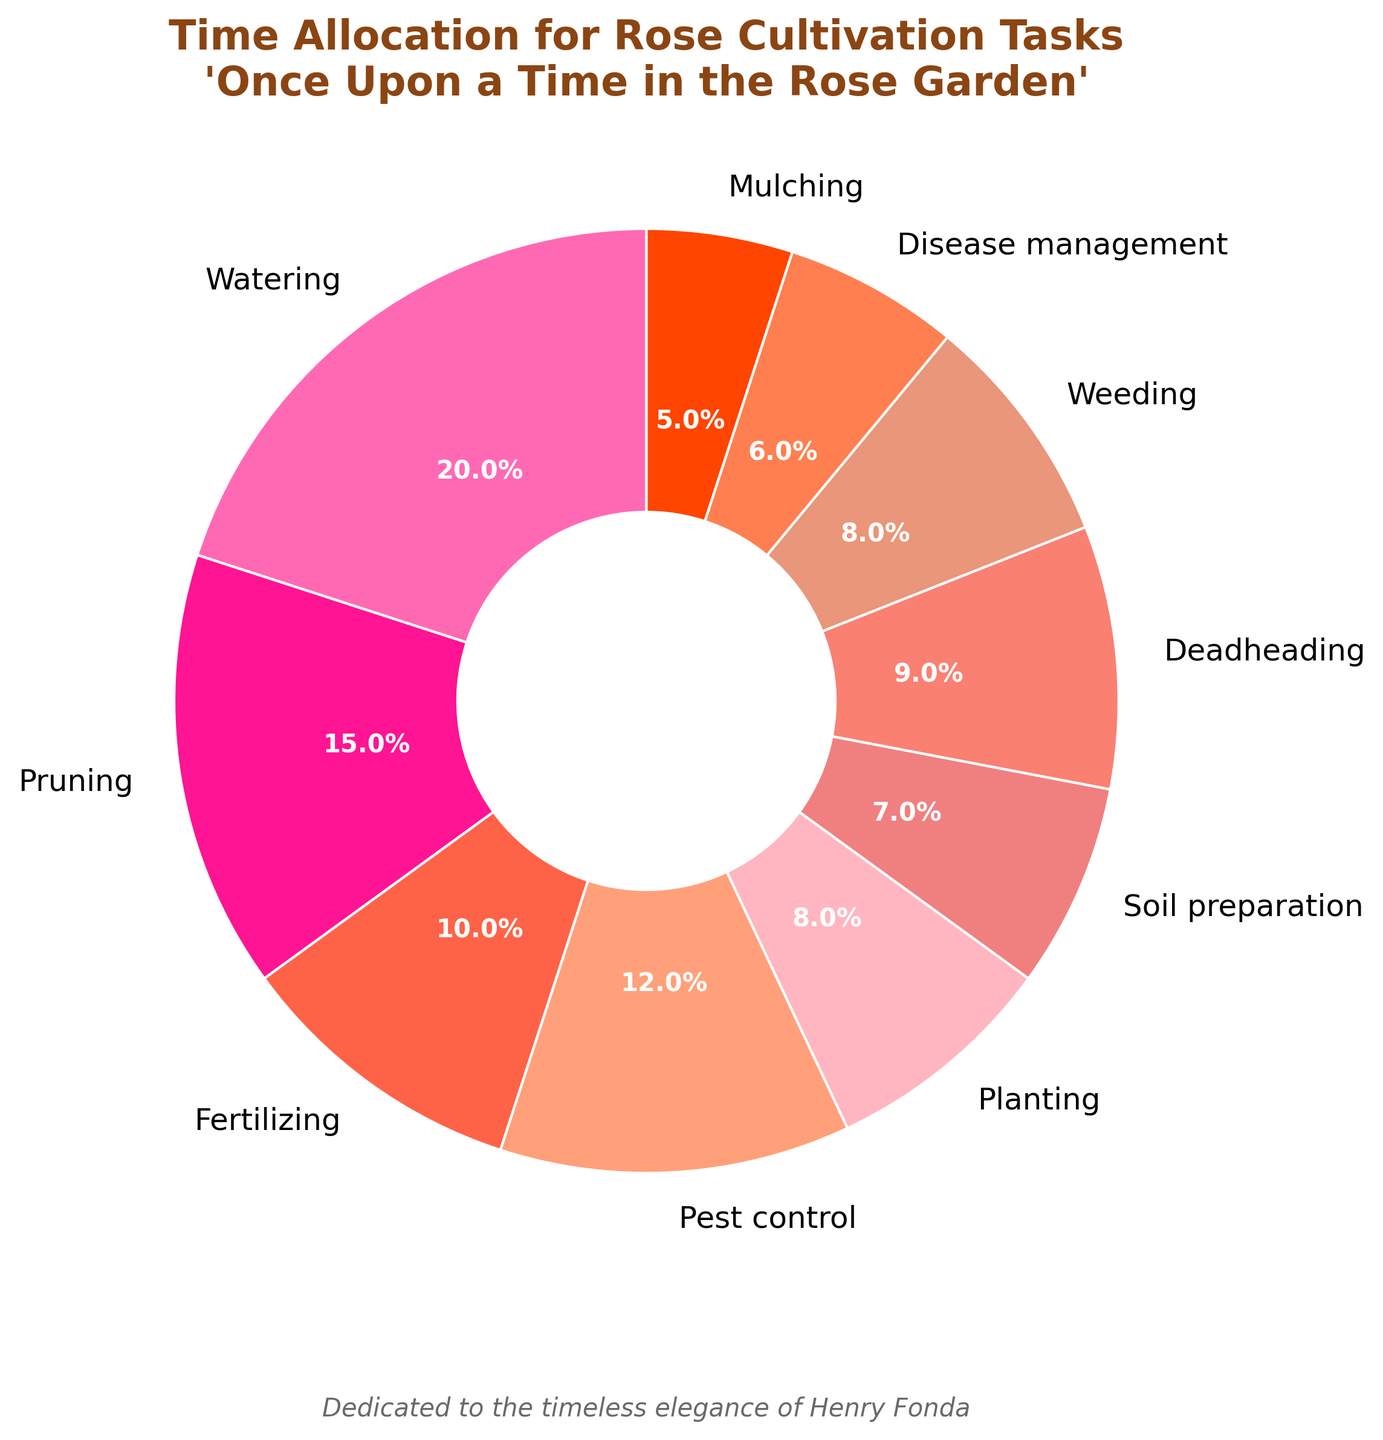Which task takes up the most time in rose cultivation? The task that has the highest percentage in the pie chart represents the task that takes up the most time. Here, Watering has the highest percentage of 20%.
Answer: Watering What is the combined percentage of time spent on planting and weeding? To find the combined percentage, add the percentages of Planting and Weeding. Planting has 8% and Weeding has 8%, so the total is 8% + 8% = 16%.
Answer: 16% Which task takes up more time, Deadheading or Fertilizing? Compare the percentages associated with Deadheading and Fertilizing tasks. Deadheading has 9% while Fertilizing has 10%. Therefore, Fertilizing takes up more time.
Answer: Fertilizing What is the least time-consuming task in rose cultivation? The least time-consuming task will have the smallest percentage in the pie chart. Here, Mulching is the least with 5%.
Answer: Mulching How much more time is spent on Pest control compared to Disease management? Subtract the percentage of Disease Management from Pest Control. Pest Control has 12% and Disease Management has 6%, so the difference is 12% - 6% = 6%.
Answer: 6% What is the total percentage of time spent on tasks related to the soil (Soil preparation and Mulching)? Add the percentages of Soil Preparation and Mulching together. Soil Preparation has 7% and Mulching has 5%, so total is 7% + 5% = 12%.
Answer: 12% Which tasks combined take up as much time as Pruning? Identify tasks whose percentages add up to the percentage of Pruning. Pruning is 15%, and combinations like Fertilizing (10%) and Disease Management (5%) add up to 15%.
Answer: Fertilizing and Disease Management What is the difference in percentage between the most time-consuming task and the least time-consuming task? Subtract the percentage of the least time-consuming task from the percentage of the most time-consuming task. Watering is 20% and Mulching is 5%, so the difference is 20% - 5% = 15%.
Answer: 15% Which task is represented by the color red in the pie chart? Identify the task whose pie section is colored red. In the provided color coding, the section colored red corresponds to Weeding.
Answer: Weeding 